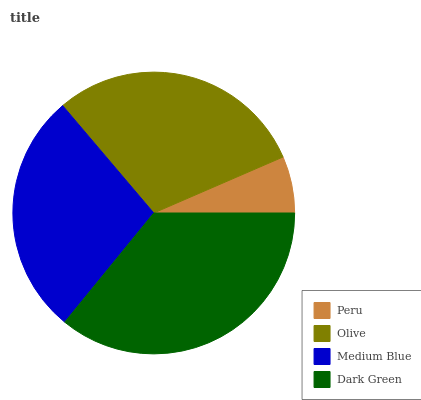Is Peru the minimum?
Answer yes or no. Yes. Is Dark Green the maximum?
Answer yes or no. Yes. Is Olive the minimum?
Answer yes or no. No. Is Olive the maximum?
Answer yes or no. No. Is Olive greater than Peru?
Answer yes or no. Yes. Is Peru less than Olive?
Answer yes or no. Yes. Is Peru greater than Olive?
Answer yes or no. No. Is Olive less than Peru?
Answer yes or no. No. Is Olive the high median?
Answer yes or no. Yes. Is Medium Blue the low median?
Answer yes or no. Yes. Is Peru the high median?
Answer yes or no. No. Is Olive the low median?
Answer yes or no. No. 